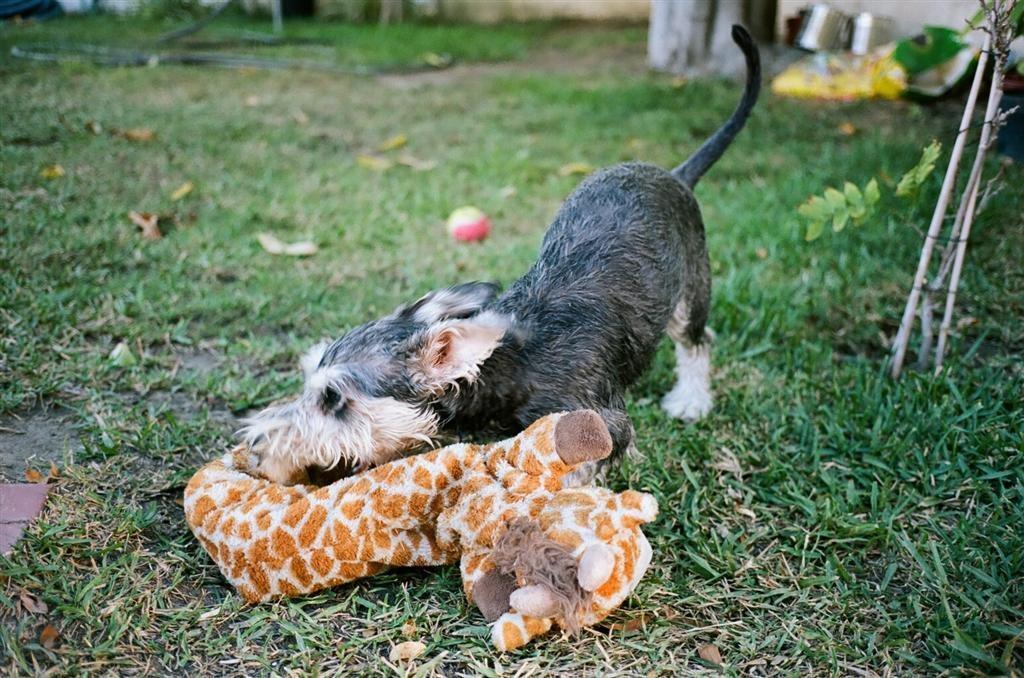In one or two sentences, can you explain what this image depicts? In this picture I can observe a dog playing with a toy which is in orange and white color. This dog is in black and white color. There is some grass on the ground. I can observe a ball on the ground in the middle of the picture. 